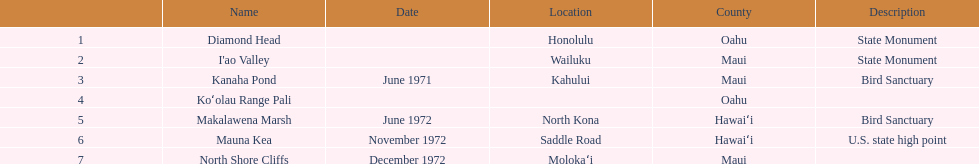How many dates are in 1972? 3. 